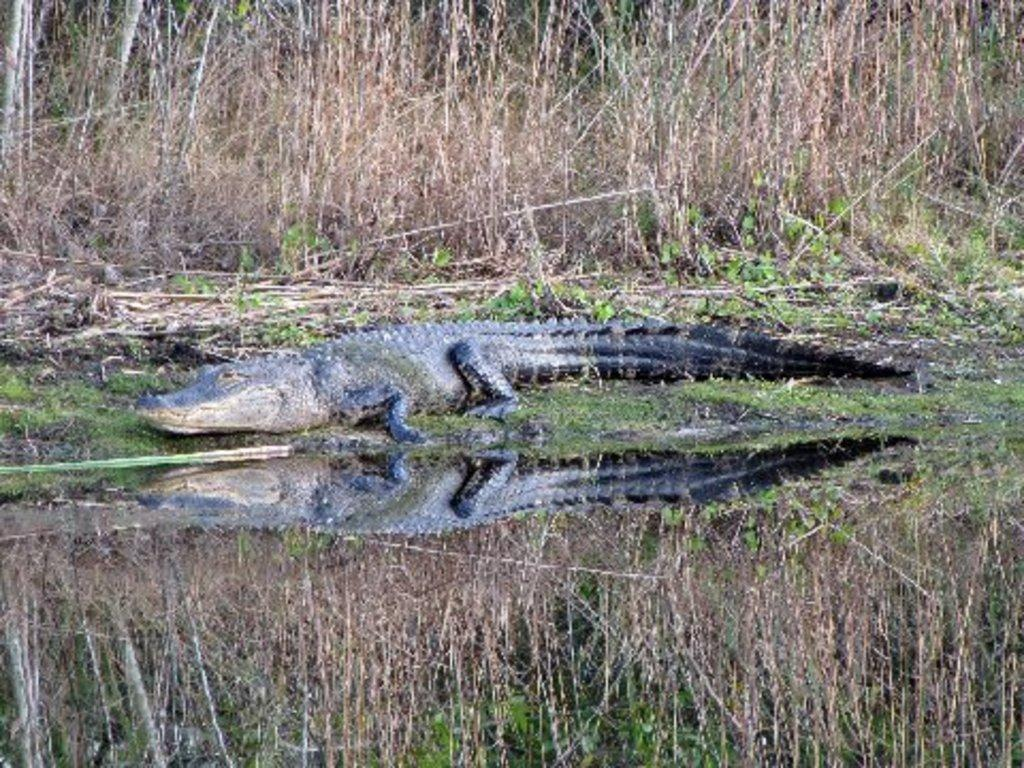What is the main subject in the center of the image? There is a crocodile in the center of the image. What is the crocodile located near in the image? The crocodile is located near a small pond in the image. What can be seen in the background of the image? There are plants and dry grass in the background of the image. What type of bird can be seen flying over the crocodile in the image? There are no birds visible in the image; it only features a crocodile, a small pond, plants, and dry grass in the background. 